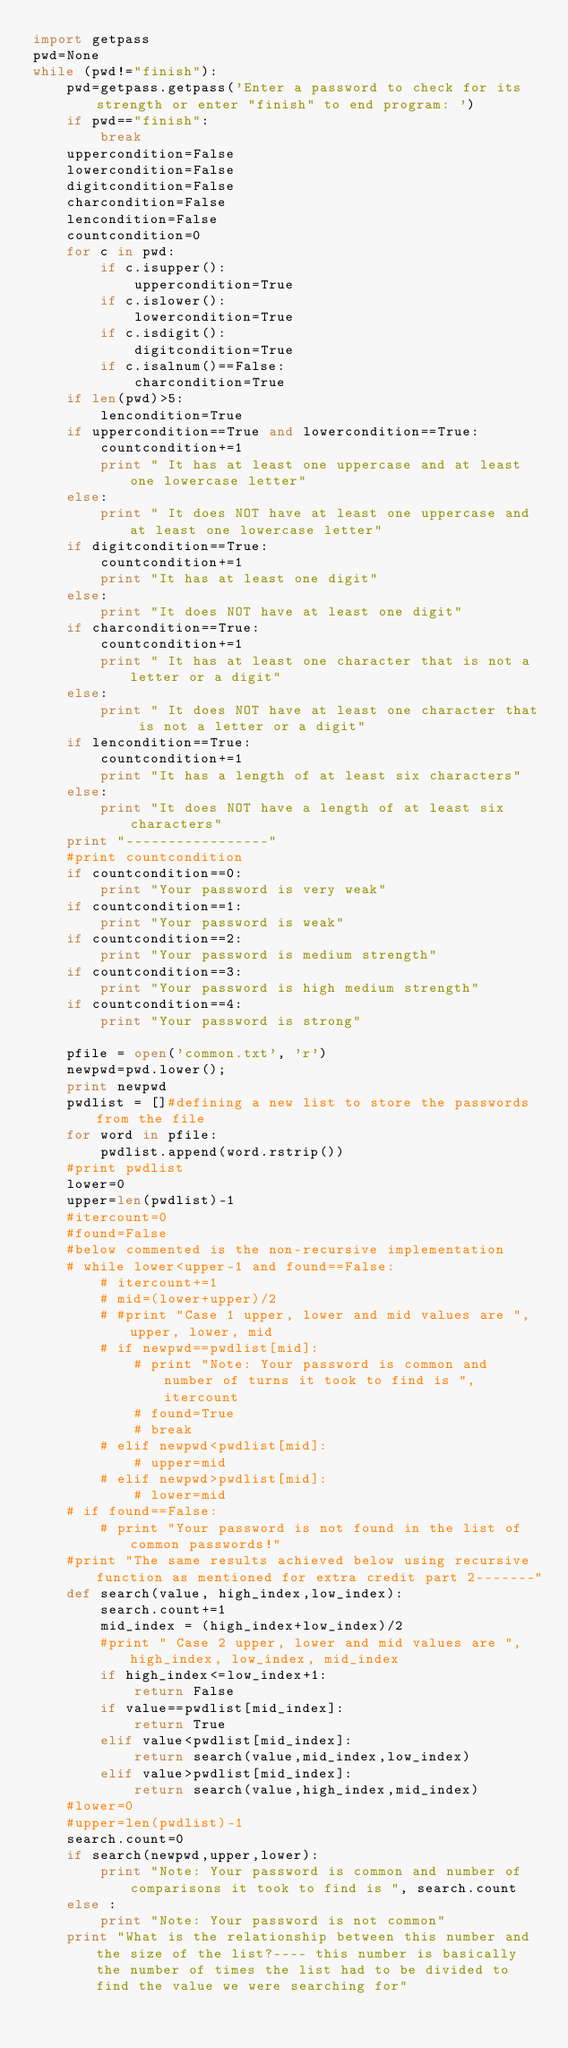<code> <loc_0><loc_0><loc_500><loc_500><_Python_>import getpass
pwd=None
while (pwd!="finish"):
	pwd=getpass.getpass('Enter a password to check for its strength or enter "finish" to end program: ')
	if pwd=="finish":
		break
	uppercondition=False
	lowercondition=False
	digitcondition=False
	charcondition=False
	lencondition=False
	countcondition=0
	for c in pwd:
		if c.isupper():
			uppercondition=True
		if c.islower():
			lowercondition=True
		if c.isdigit():
			digitcondition=True
		if c.isalnum()==False:
			charcondition=True
	if len(pwd)>5:
		lencondition=True
	if uppercondition==True and lowercondition==True:
		countcondition+=1
		print " It has at least one uppercase and at least one lowercase letter"
	else:
		print " It does NOT have at least one uppercase and at least one lowercase letter"
	if digitcondition==True:
		countcondition+=1
		print "It has at least one digit"
	else:
		print "It does NOT have at least one digit"
	if charcondition==True:
		countcondition+=1
		print " It has at least one character that is not a letter or a digit"
	else:
		print " It does NOT have at least one character that is not a letter or a digit"
	if lencondition==True:
		countcondition+=1
		print "It has a length of at least six characters"
	else:
		print "It does NOT have a length of at least six characters"
	print "-----------------"
	#print countcondition
	if countcondition==0:
		print "Your password is very weak"
	if countcondition==1:
		print "Your password is weak"
	if countcondition==2:
		print "Your password is medium strength"
	if countcondition==3:
		print "Your password is high medium strength"
	if countcondition==4:
		print "Your password is strong"
		
	pfile = open('common.txt', 'r')
	newpwd=pwd.lower();
	print newpwd
	pwdlist = []#defining a new list to store the passwords from the file
	for word in pfile:	
		pwdlist.append(word.rstrip())
	#print pwdlist
	lower=0
	upper=len(pwdlist)-1
	#itercount=0
	#found=False
	#below commented is the non-recursive implementation
	# while lower<upper-1 and found==False:
		# itercount+=1
		# mid=(lower+upper)/2
		# #print "Case 1 upper, lower and mid values are ", upper, lower, mid
		# if newpwd==pwdlist[mid]:
			# print "Note: Your password is common and number of turns it took to find is ", itercount
			# found=True
			# break
		# elif newpwd<pwdlist[mid]:
			# upper=mid
		# elif newpwd>pwdlist[mid]:
			# lower=mid
	# if found==False:
		# print "Your password is not found in the list of common passwords!"
	#print "The same results achieved below using recursive function as mentioned for extra credit part 2-------"
	def search(value, high_index,low_index):
		search.count+=1
		mid_index = (high_index+low_index)/2
		#print " Case 2 upper, lower and mid values are ", high_index, low_index, mid_index
		if high_index<=low_index+1:
			return False
		if value==pwdlist[mid_index]:
			return True
		elif value<pwdlist[mid_index]:
			return search(value,mid_index,low_index)
		elif value>pwdlist[mid_index]:
			return search(value,high_index,mid_index)
	#lower=0
	#upper=len(pwdlist)-1
	search.count=0
	if search(newpwd,upper,lower):
		print "Note: Your password is common and number of comparisons it took to find is ", search.count
	else :
		print "Note: Your password is not common"
	print "What is the relationship between this number and the size of the list?---- this number is basically the number of times the list had to be divided to find the value we were searching for"</code> 